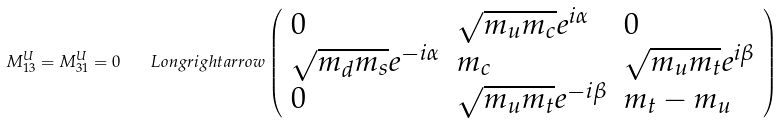Convert formula to latex. <formula><loc_0><loc_0><loc_500><loc_500>M _ { 1 3 } ^ { U } = M _ { 3 1 } ^ { U } = 0 \quad L o n g r i g h t a r r o w \left ( \begin{array} { l l l } 0 & \sqrt { m _ { u } m _ { c } } e ^ { i \alpha } & 0 \\ \sqrt { m _ { d } m _ { s } } e ^ { - i \alpha } & m _ { c } & \sqrt { m _ { u } m _ { t } } e ^ { i \beta } \\ 0 & \sqrt { m _ { u } m _ { t } } e ^ { - i \beta } & m _ { t } - m _ { u } \end{array} \right )</formula> 